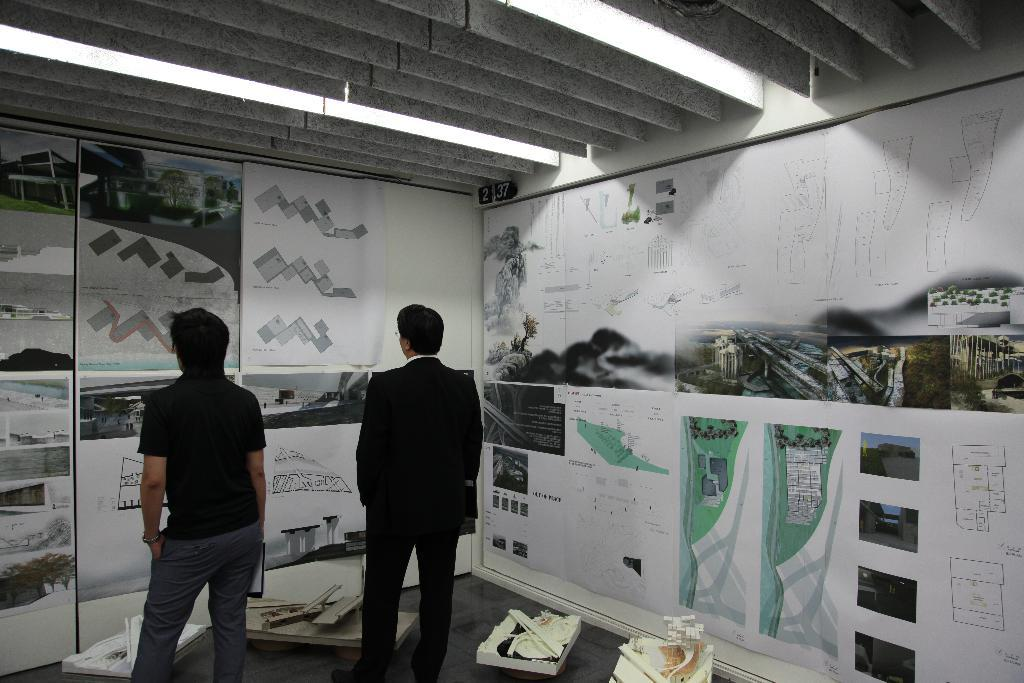What can be seen in the image? There are people standing in the image. What is visible in the background of the image? There are posters on the wall in the background. What is at the top of the image? There is a roof visible at the top of the image. What is on the floor at the bottom of the image? There are objects on the floor at the bottom of the image. Can you see any trains in the middle of the image? There are no trains present in the image. Is there a lake visible in the background of the image? There is no lake visible in the background of the image; only posters on the wall can be seen. 